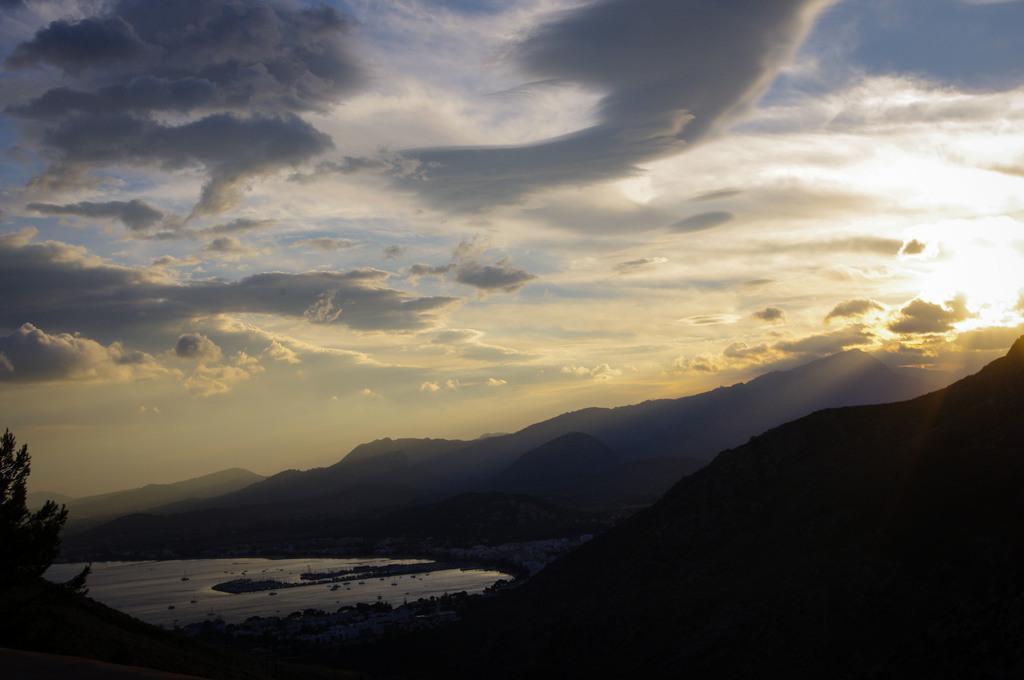Could you give a brief overview of what you see in this image? In this picture, we see water and ice. In the left bottom of the picture, we see a tree. There are hills in the background. At the top of the picture, we see the clouds, sky and the sun. 